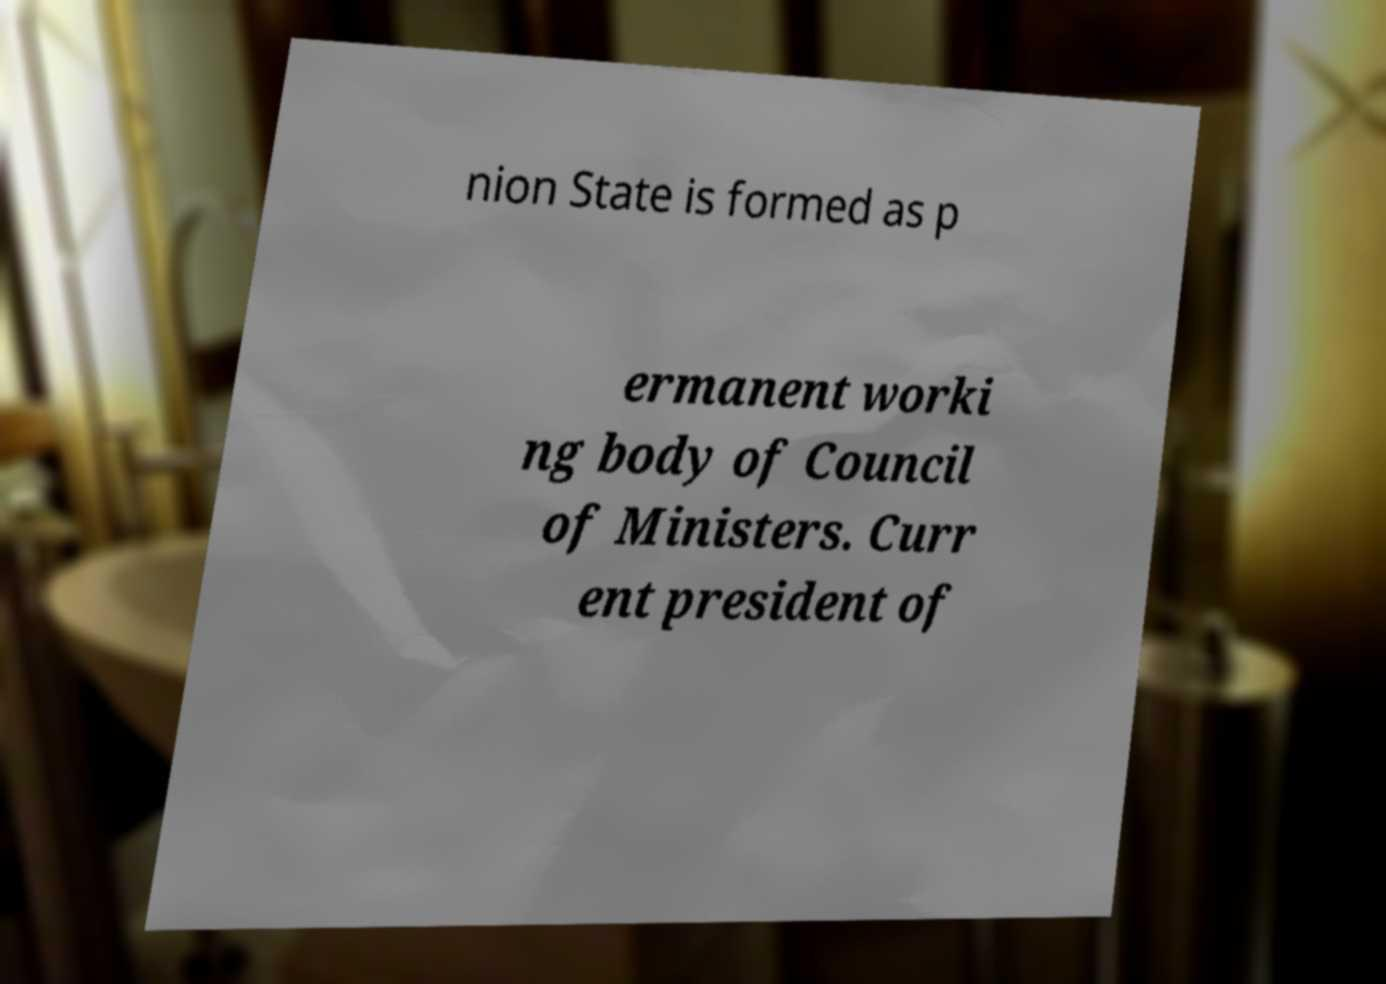Please read and relay the text visible in this image. What does it say? nion State is formed as p ermanent worki ng body of Council of Ministers. Curr ent president of 